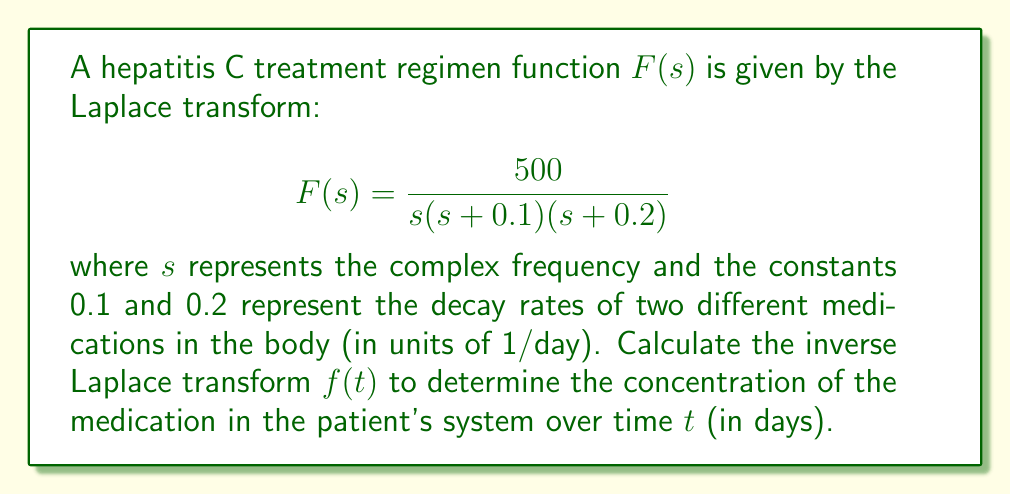Can you solve this math problem? To find the inverse Laplace transform, we'll use the partial fraction decomposition method:

1) First, decompose $F(s)$ into partial fractions:
   $$F(s) = \frac{A}{s} + \frac{B}{s+0.1} + \frac{C}{s+0.2}$$

2) Find the common denominator:
   $$\frac{500}{s(s+0.1)(s+0.2)} = \frac{A(s+0.1)(s+0.2) + Bs(s+0.2) + Cs(s+0.1)}{s(s+0.1)(s+0.2)}$$

3) Equate the numerators:
   $$500 = A(s+0.1)(s+0.2) + Bs(s+0.2) + Cs(s+0.1)$$

4) Solve for A, B, and C:
   - When $s=0$: $500 = 0.02A$, so $A = 25000$
   - When $s=-0.1$: $500 = -0.01C$, so $C = -50000$
   - When $s=-0.2$: $500 = -0.02B$, so $B = -25000$

5) Rewrite $F(s)$ with the solved coefficients:
   $$F(s) = \frac{25000}{s} - \frac{25000}{s+0.1} - \frac{50000}{s+0.2}$$

6) Use the inverse Laplace transform properties:
   - $\mathcal{L}^{-1}\{\frac{1}{s}\} = 1$
   - $\mathcal{L}^{-1}\{\frac{1}{s+a}\} = e^{-at}$

7) Apply the inverse Laplace transform:
   $$f(t) = 25000 - 25000e^{-0.1t} - 50000e^{-0.2t}$$

This function represents the concentration of medication in the patient's system over time $t$ in days.
Answer: $f(t) = 25000 - 25000e^{-0.1t} - 50000e^{-0.2t}$ 